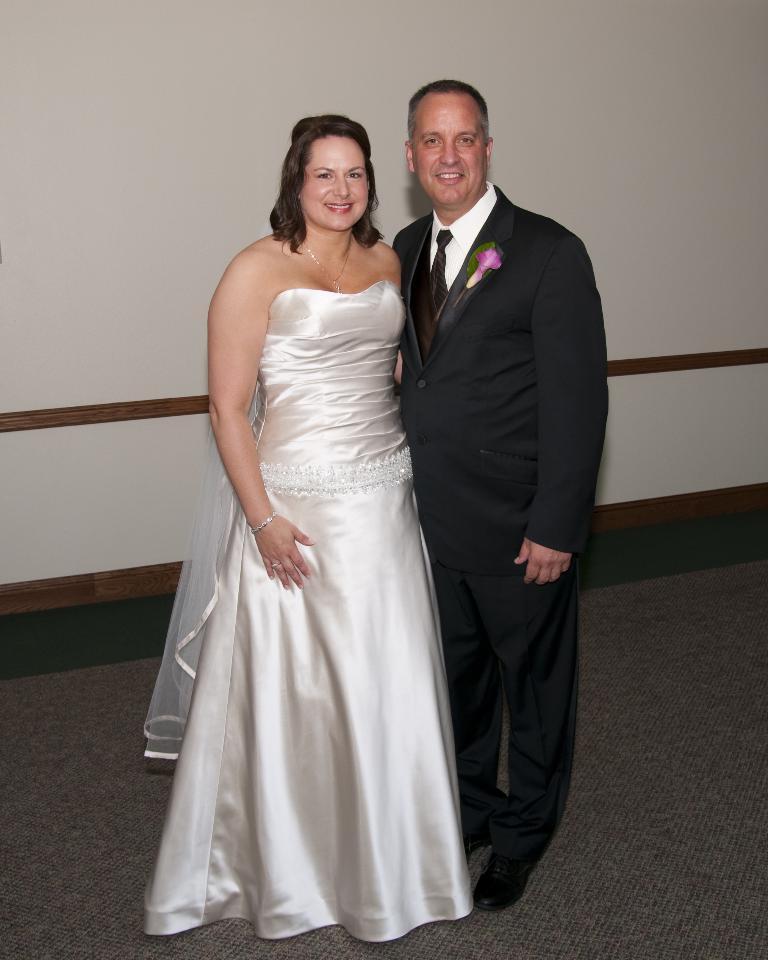How would you summarize this image in a sentence or two? In this picture we can see a man and a woman standing here, there are smiling, in the background there is a wall, this man wore a suit. 